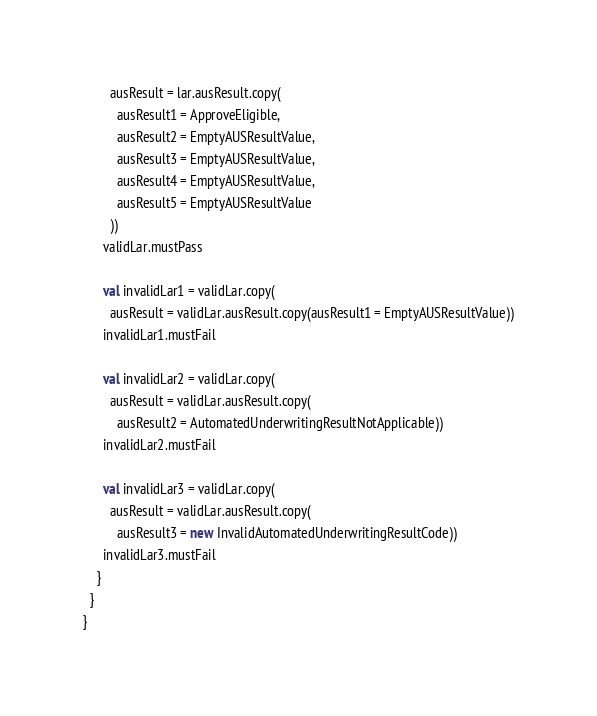Convert code to text. <code><loc_0><loc_0><loc_500><loc_500><_Scala_>        ausResult = lar.ausResult.copy(
          ausResult1 = ApproveEligible,
          ausResult2 = EmptyAUSResultValue,
          ausResult3 = EmptyAUSResultValue,
          ausResult4 = EmptyAUSResultValue,
          ausResult5 = EmptyAUSResultValue
        ))
      validLar.mustPass

      val invalidLar1 = validLar.copy(
        ausResult = validLar.ausResult.copy(ausResult1 = EmptyAUSResultValue))
      invalidLar1.mustFail

      val invalidLar2 = validLar.copy(
        ausResult = validLar.ausResult.copy(
          ausResult2 = AutomatedUnderwritingResultNotApplicable))
      invalidLar2.mustFail

      val invalidLar3 = validLar.copy(
        ausResult = validLar.ausResult.copy(
          ausResult3 = new InvalidAutomatedUnderwritingResultCode))
      invalidLar3.mustFail
    }
  }
}
</code> 